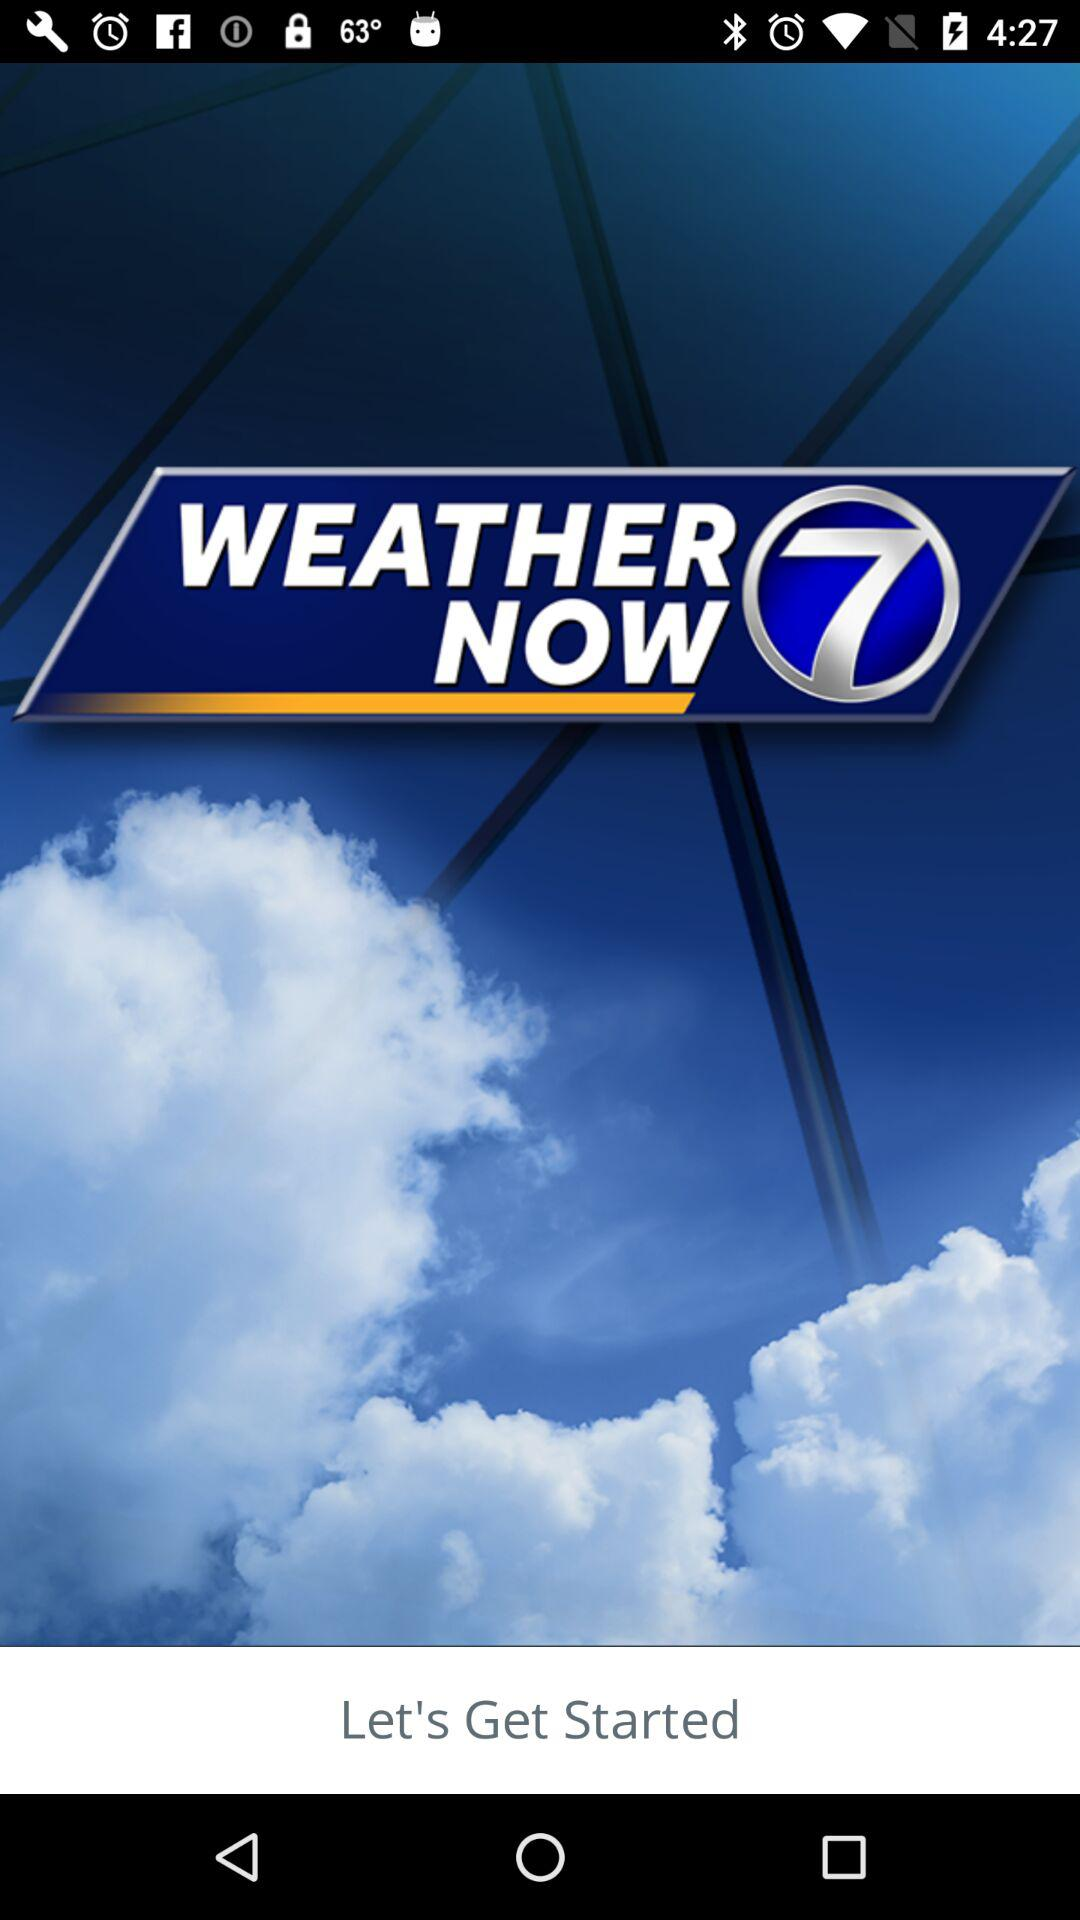What is the name of the application? The name of the application is "WEATHER NOW". 